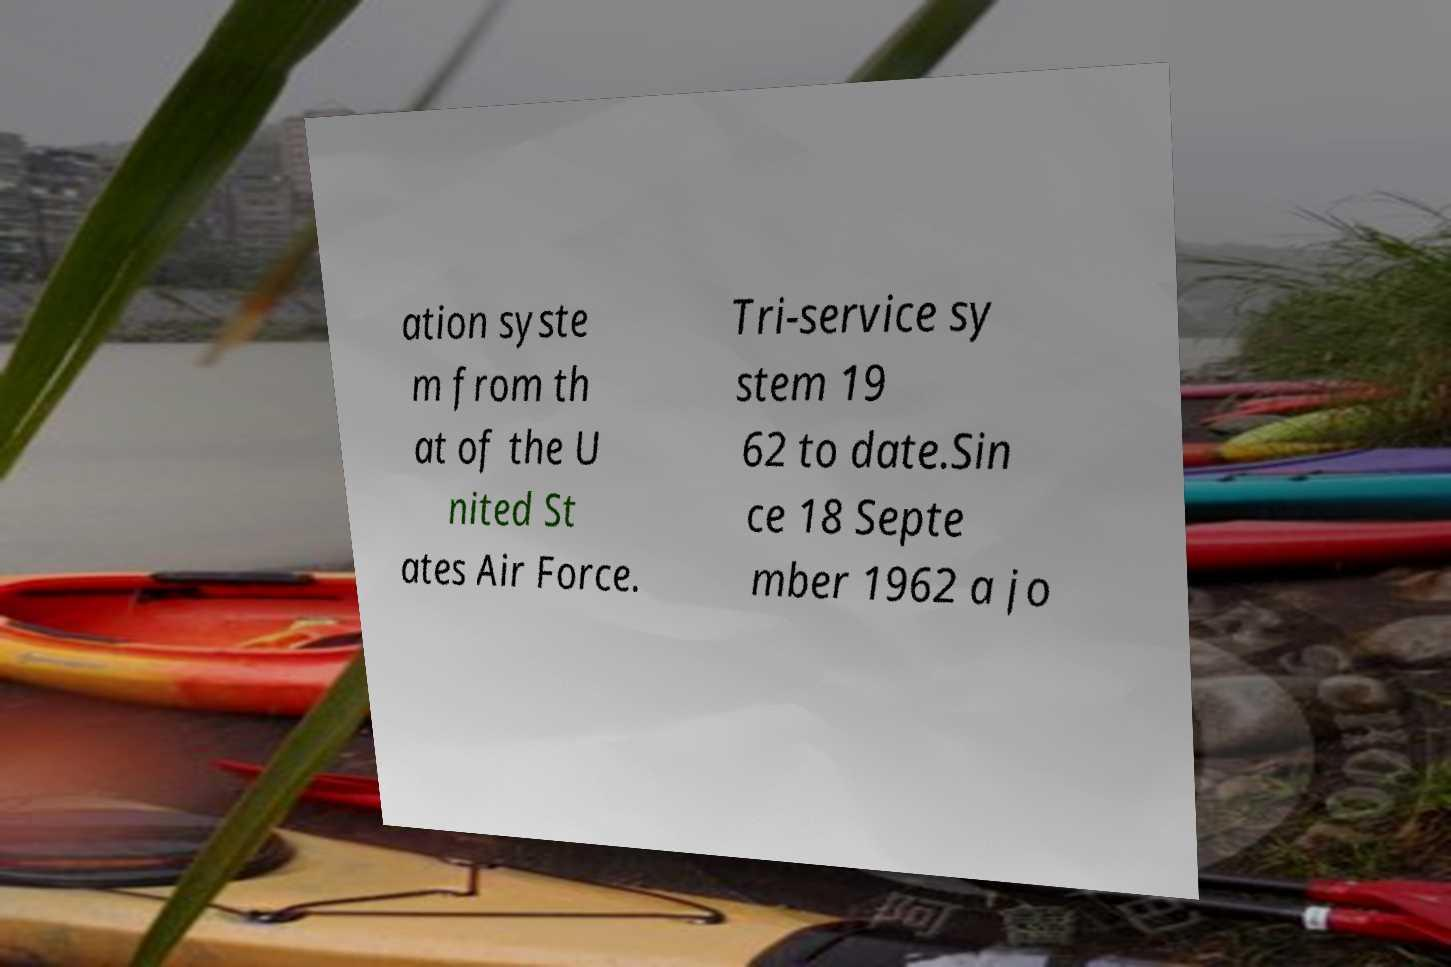Please read and relay the text visible in this image. What does it say? ation syste m from th at of the U nited St ates Air Force. Tri-service sy stem 19 62 to date.Sin ce 18 Septe mber 1962 a jo 